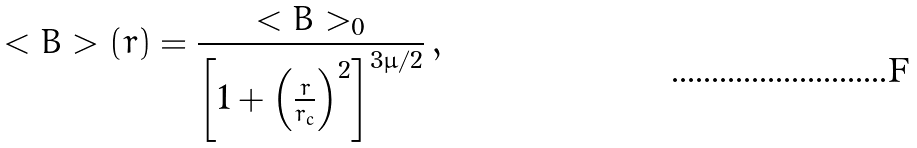<formula> <loc_0><loc_0><loc_500><loc_500>< { B } > ( r ) = \frac { < { B } > _ { 0 } } { \left [ 1 + \left ( \frac { r } { r _ { c } } \right ) ^ { 2 } \right ] ^ { 3 \mu / 2 } } \, ,</formula> 